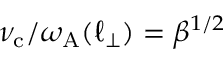Convert formula to latex. <formula><loc_0><loc_0><loc_500><loc_500>\nu _ { c } / \omega _ { A } ( \ell _ { \perp } ) = \beta ^ { 1 / 2 }</formula> 